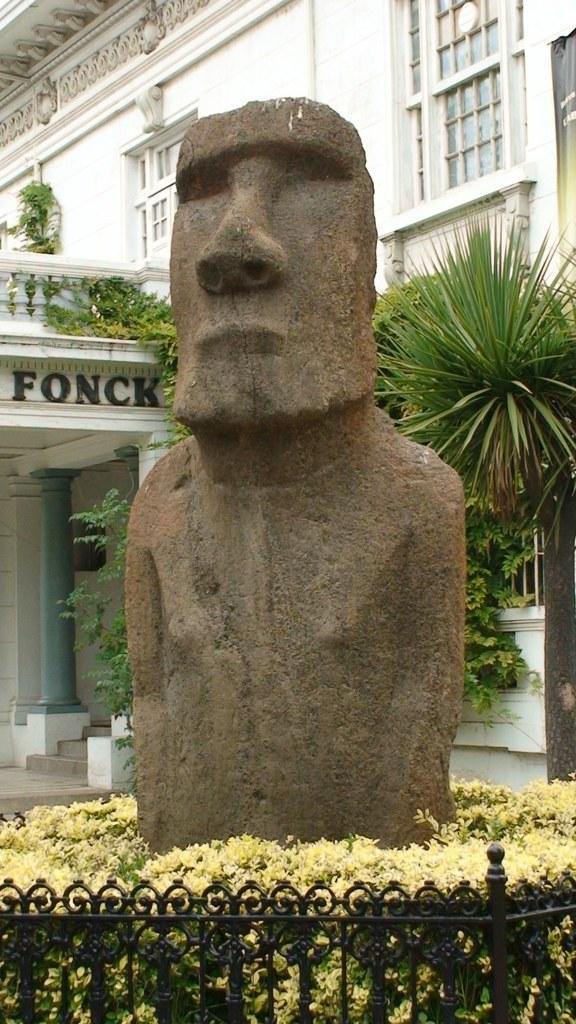Please provide a concise description of this image. Here we can see a sculpture, plants, and a fence. In the background we can see a building. 